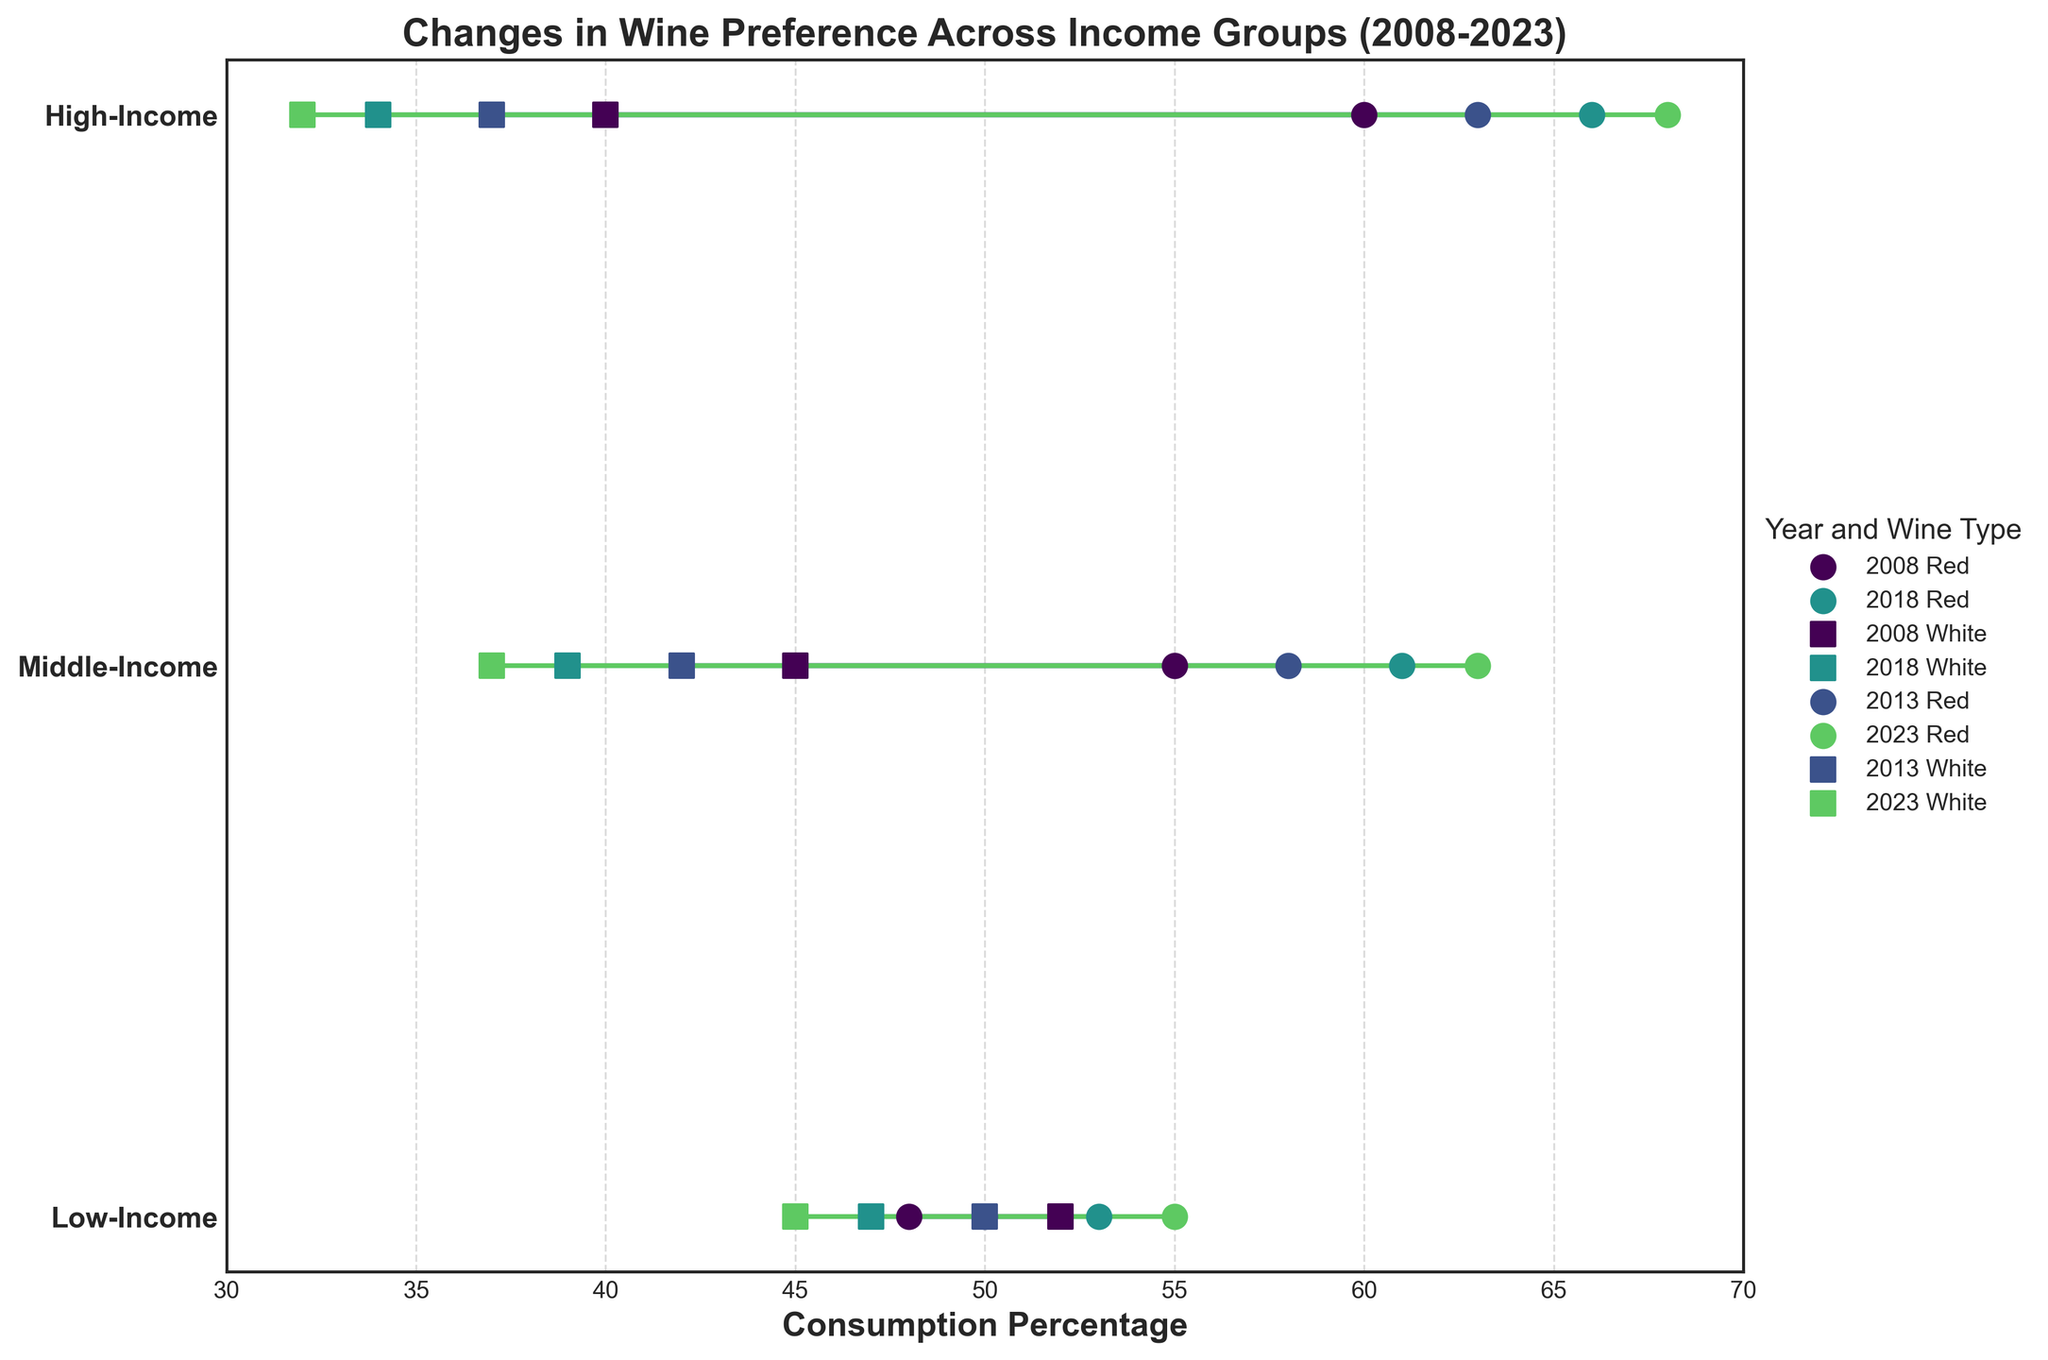What's the title of this plot? The title is mentioned at the top of the figure. It provides an overview of what the plot represents.
Answer: Changes in Wine Preference Across Income Groups (2008-2023) What is the general trend in red wine consumption for the High-Income group over time? To answer, look at the scatter points for red wine from 2008 to 2023 for the High-Income group and observe either increase, decrease, or steadiness.
Answer: Increasing How did the consumption percentage of white wine change for the Middle-Income group from 2008 to 2023? Observe the white wine data points for the Middle-Income group from 2008 to 2023 and calculate the difference in percentage.
Answer: Decreased by 8% Which income group had the highest consumption of red wine in 2023? Compare the red wine consumption percentages for all income groups for the year 2023.
Answer: High-Income By how much did red wine consumption increase in the Low-Income group from 2008 to 2023? Subtract the red wine consumption percentage in 2008 from the one in 2023 for the Low-Income group.
Answer: 7% Compare the consumption percentages of red and white wine for the High-Income group in 2018. Which was higher and by how much? Identify the consumption percentages for red and white wine for the High-Income group in 2018, and then calculate the difference.
Answer: Red was higher by 32% What unique attribute about the Middle-Income group's wine preference can be observed for the year 2013? Examine the trend line and scatter points for the Middle-Income group in 2013 and observe any distinctive patterns.
Answer: Red wine preference increased significantly while white decreased What is the color used to represent the year 2008 in the plot? Each year is represented by a unique color. Identify the color associated with the data points and lines for the year 2008.
Answer: Color representing 2008 How did the consumption percentages for red wine in the Low-Income group compare between 2008 and 2013? Check the red wine consumption percentages for Low-Income group from 2008 and 2013 and see if they increased, decreased, or stayed the same.
Answer: Increased by 2% Which year had the smallest difference in consumption percentages for red and white wine for the Low-Income group? Calculate the difference in red and white wine consumption percentages for each year for the Low-Income group and identify the year with the smallest difference.
Answer: 2013 